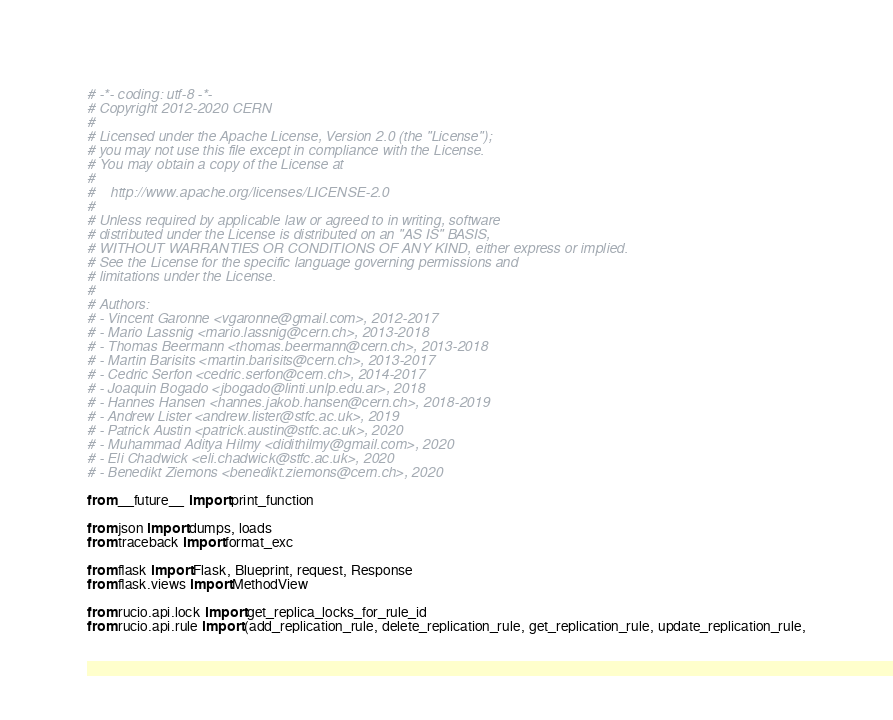Convert code to text. <code><loc_0><loc_0><loc_500><loc_500><_Python_># -*- coding: utf-8 -*-
# Copyright 2012-2020 CERN
#
# Licensed under the Apache License, Version 2.0 (the "License");
# you may not use this file except in compliance with the License.
# You may obtain a copy of the License at
#
#    http://www.apache.org/licenses/LICENSE-2.0
#
# Unless required by applicable law or agreed to in writing, software
# distributed under the License is distributed on an "AS IS" BASIS,
# WITHOUT WARRANTIES OR CONDITIONS OF ANY KIND, either express or implied.
# See the License for the specific language governing permissions and
# limitations under the License.
#
# Authors:
# - Vincent Garonne <vgaronne@gmail.com>, 2012-2017
# - Mario Lassnig <mario.lassnig@cern.ch>, 2013-2018
# - Thomas Beermann <thomas.beermann@cern.ch>, 2013-2018
# - Martin Barisits <martin.barisits@cern.ch>, 2013-2017
# - Cedric Serfon <cedric.serfon@cern.ch>, 2014-2017
# - Joaquin Bogado <jbogado@linti.unlp.edu.ar>, 2018
# - Hannes Hansen <hannes.jakob.hansen@cern.ch>, 2018-2019
# - Andrew Lister <andrew.lister@stfc.ac.uk>, 2019
# - Patrick Austin <patrick.austin@stfc.ac.uk>, 2020
# - Muhammad Aditya Hilmy <didithilmy@gmail.com>, 2020
# - Eli Chadwick <eli.chadwick@stfc.ac.uk>, 2020
# - Benedikt Ziemons <benedikt.ziemons@cern.ch>, 2020

from __future__ import print_function

from json import dumps, loads
from traceback import format_exc

from flask import Flask, Blueprint, request, Response
from flask.views import MethodView

from rucio.api.lock import get_replica_locks_for_rule_id
from rucio.api.rule import (add_replication_rule, delete_replication_rule, get_replication_rule, update_replication_rule,</code> 